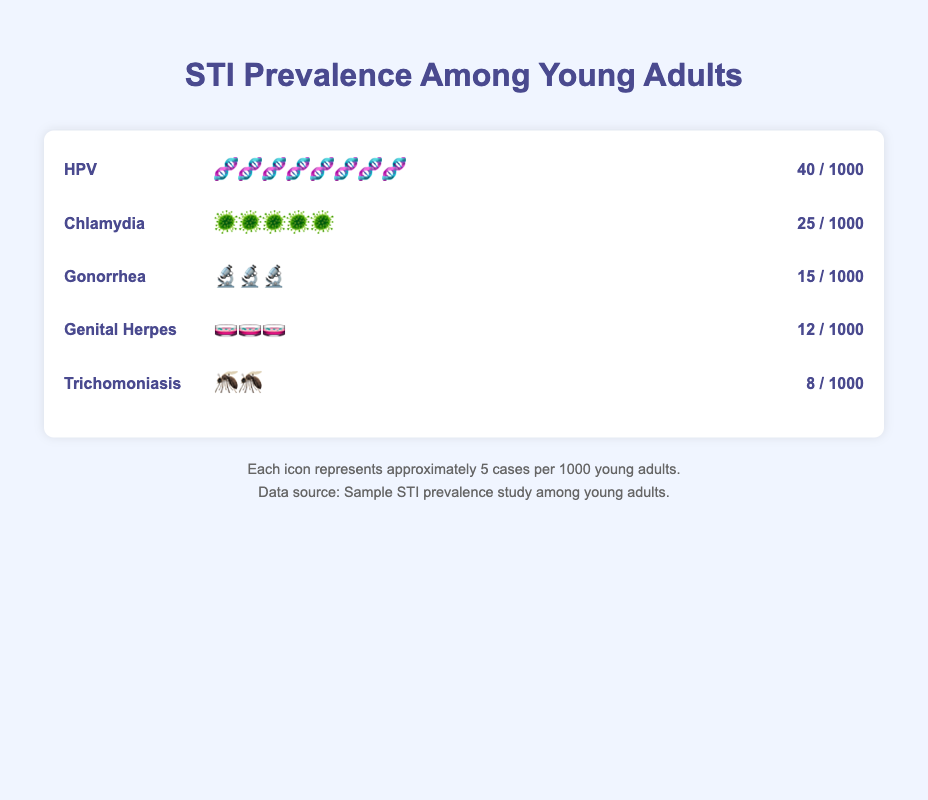What's the prevalence of HPV among young adults? The figure shows that the prevalence of HPV is represented by 8 icons, each icon representing 5 cases per 1000 young adults. Therefore, 8 icons * 5 cases each equals 40 cases per 1000 young adults.
Answer: 40 cases per 1000 Which STI has the lowest prevalence among young adults? The figure shows different STIs and their respective cases per 1000 young adults. Trichomoniasis has 8 cases per 1000, which is the lowest among the listed STIs.
Answer: Trichomoniasis How many more cases of Chlamydia are there compared to Genital Herpes? Chlamydia has 25 cases per 1000 and Genital Herpes has 12 cases per 1000. The difference is 25 - 12 = 13 cases per 1000.
Answer: 13 cases per 1000 Rank the STIs from most to least prevalent. Based on the number of cases per 1000 young adults, the STIs are ranked as follows: HPV (40 cases), Chlamydia (25 cases), Gonorrhea (15 cases), Genital Herpes (12 cases), and Trichomoniasis (8 cases).
Answer: HPV, Chlamydia, Gonorrhea, Genital Herpes, Trichomoniasis What is the combined prevalence of Gonorrhea and Genital Herpes? Gonorrhea has 15 cases per 1000 and Genital Herpes has 12 cases per 1000. The combined prevalence is 15 + 12 = 27 cases per 1000.
Answer: 27 cases per 1000 Which STI is represented by the greatest number of icons? The figure uses icons to represent the prevalence of each STI. HPV is represented by 8 icons, which is the greatest number among all the listed STIs.
Answer: HPV What fraction of the total prevalence is made up by Trichomoniasis? The total prevalence is calculated by summing all cases per 1000 (40 + 25 + 15 + 12 + 8 = 100). Trichomoniasis represents 8 out of 100, which simplifies to 8/100 or 1/12.5.
Answer: 1/12.5 Are there more cases of Gonorrhea or Chlamydia among young adults? The figure shows that Chlamydia has 25 cases per 1000, whereas Gonorrhea has 15 cases per 1000. Chlamydia has more cases.
Answer: Chlamydia What is the difference in prevalence between the most and least common STIs? The most common STI is HPV with 40 cases per 1000, and the least common is Trichomoniasis with 8 cases per 1000. The difference is 40 - 8 = 32 cases per 1000.
Answer: 32 cases per 1000 